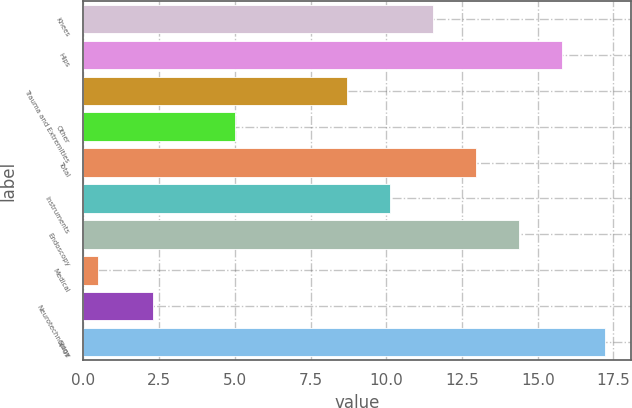Convert chart to OTSL. <chart><loc_0><loc_0><loc_500><loc_500><bar_chart><fcel>Knees<fcel>Hips<fcel>Trauma and Extremities<fcel>Other<fcel>Total<fcel>Instruments<fcel>Endoscopy<fcel>Medical<fcel>Neurotechnology<fcel>Spine<nl><fcel>11.54<fcel>15.8<fcel>8.7<fcel>5<fcel>12.96<fcel>10.12<fcel>14.38<fcel>0.5<fcel>2.3<fcel>17.22<nl></chart> 